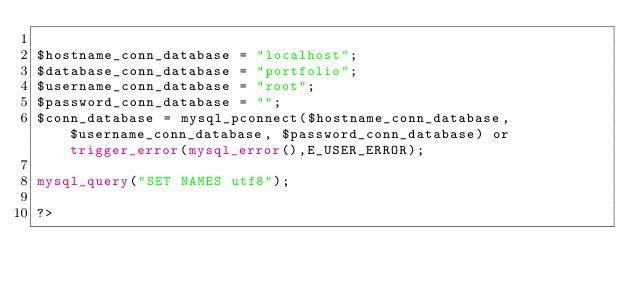Convert code to text. <code><loc_0><loc_0><loc_500><loc_500><_PHP_>
$hostname_conn_database = "localhost";
$database_conn_database = "portfolio";
$username_conn_database = "root";
$password_conn_database = "";
$conn_database = mysql_pconnect($hostname_conn_database, $username_conn_database, $password_conn_database) or trigger_error(mysql_error(),E_USER_ERROR); 

mysql_query("SET NAMES utf8"); 

?></code> 